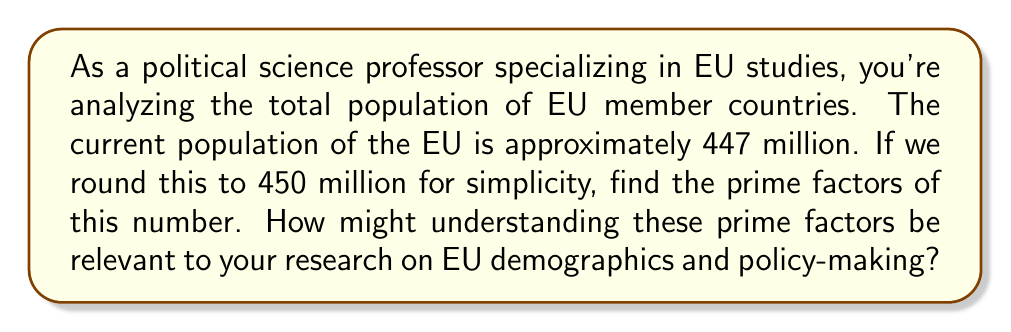Show me your answer to this math problem. To find the prime factors of 450 million, we'll use the following steps:

1) First, let's express 450 million in standard form:
   $450,000,000 = 4.5 \times 10^8$

2) Now, let's break this down:
   $450,000,000 = 2^7 \times 3^2 \times 5^6$

   Here's how we arrived at this:
   
   $$\begin{align}
   450,000,000 &= 2 \times 225,000,000 \\
   &= 2^2 \times 112,500,000 \\
   &= 2^3 \times 56,250,000 \\
   &= 2^4 \times 28,125,000 \\
   &= 2^5 \times 14,062,500 \\
   &= 2^6 \times 7,031,250 \\
   &= 2^7 \times 3,515,625 \\
   &= 2^7 \times 3 \times 1,171,875 \\
   &= 2^7 \times 3^2 \times 390,625 \\
   &= 2^7 \times 3^2 \times 5 \times 78,125 \\
   &= 2^7 \times 3^2 \times 5^2 \times 15,625 \\
   &= 2^7 \times 3^2 \times 5^3 \times 3,125 \\
   &= 2^7 \times 3^2 \times 5^4 \times 625 \\
   &= 2^7 \times 3^2 \times 5^5 \times 125 \\
   &= 2^7 \times 3^2 \times 5^6 \times 25 \\
   &= 2^7 \times 3^2 \times 5^6 \times 5^2 \\
   &= 2^7 \times 3^2 \times 5^8
   \end{align}$$

3) Therefore, the prime factors are 2, 3, and 5.

Understanding these prime factors could be relevant to EU demographics and policy-making in several ways:

a) The factor of $2^7 = 128$ might represent the binary nature of many policy decisions (yes/no votes).
b) The factor of $3^2 = 9$ could relate to the number of EU institutions or key policy areas.
c) The factor of $5^8 = 390,625$ might correspond to the scale of EU operations, from local to continental levels.

These mathematical patterns could potentially inform strategies for proportional representation, resource allocation, or policy implementation across the diverse EU member states.
Answer: The prime factors of 450 million are 2, 3, and 5, with the full prime factorization being $2^7 \times 3^2 \times 5^8$. 